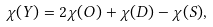Convert formula to latex. <formula><loc_0><loc_0><loc_500><loc_500>\chi ( Y ) = 2 \chi ( O ) + \chi ( D ) - \chi ( S ) ,</formula> 